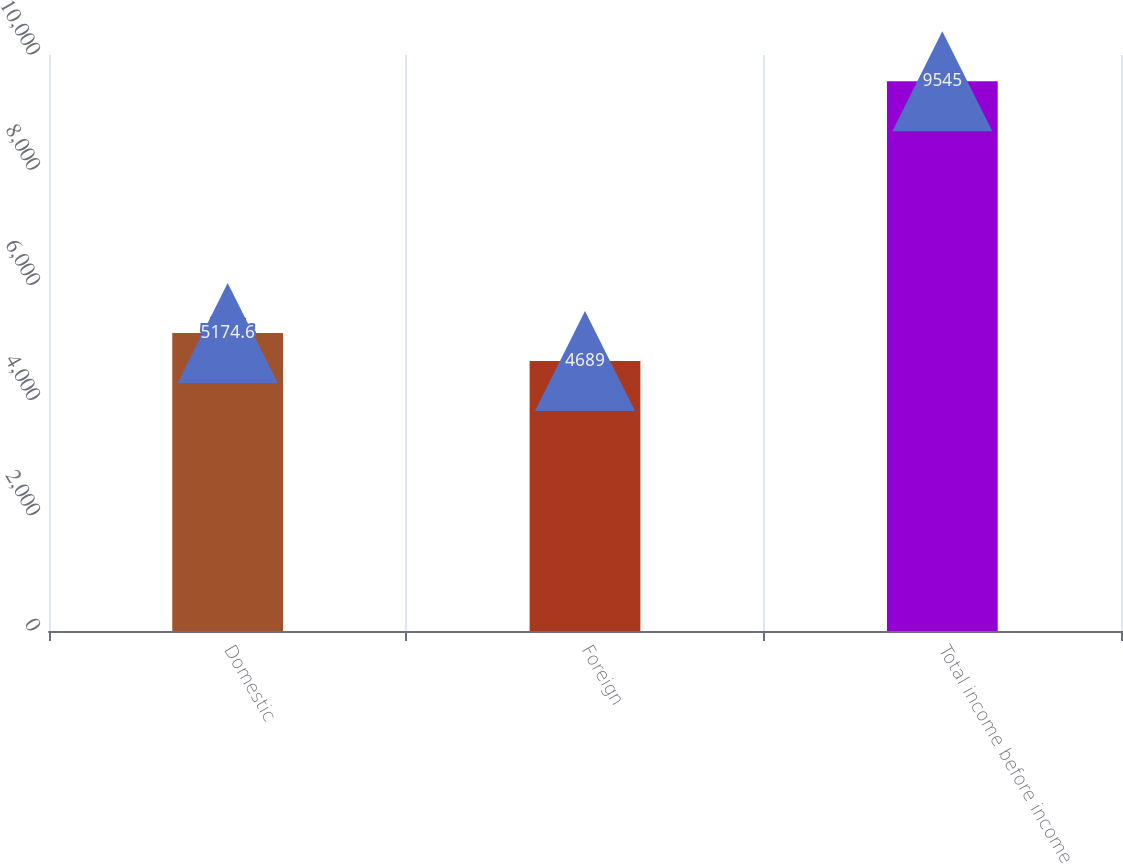Convert chart. <chart><loc_0><loc_0><loc_500><loc_500><bar_chart><fcel>Domestic<fcel>Foreign<fcel>Total income before income<nl><fcel>5174.6<fcel>4689<fcel>9545<nl></chart> 